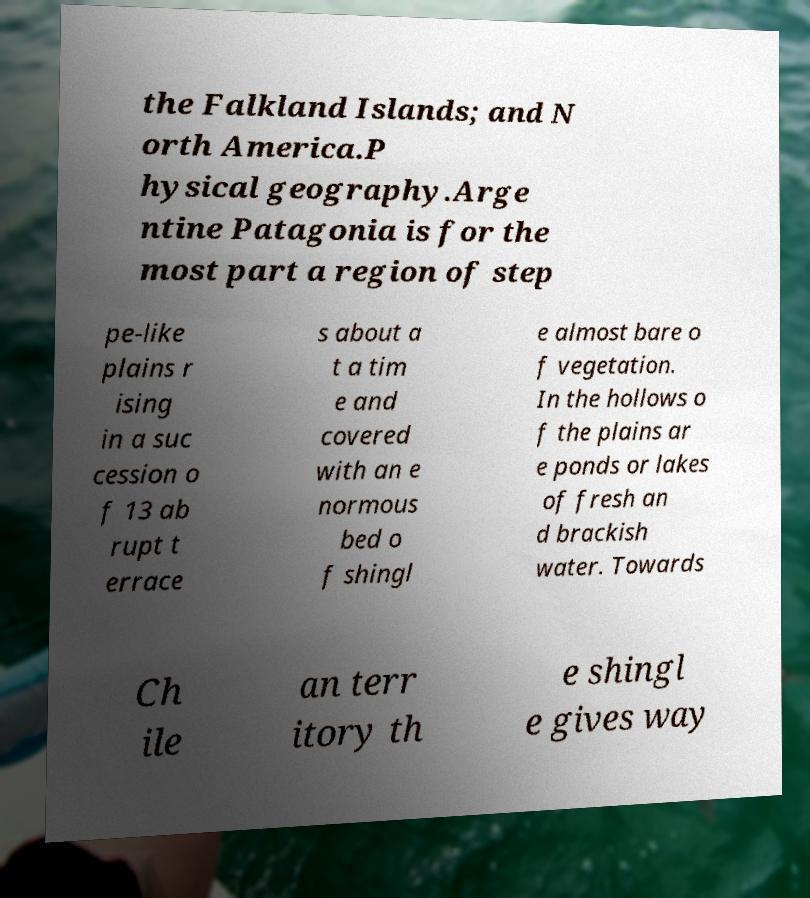Can you read and provide the text displayed in the image?This photo seems to have some interesting text. Can you extract and type it out for me? the Falkland Islands; and N orth America.P hysical geography.Arge ntine Patagonia is for the most part a region of step pe-like plains r ising in a suc cession o f 13 ab rupt t errace s about a t a tim e and covered with an e normous bed o f shingl e almost bare o f vegetation. In the hollows o f the plains ar e ponds or lakes of fresh an d brackish water. Towards Ch ile an terr itory th e shingl e gives way 